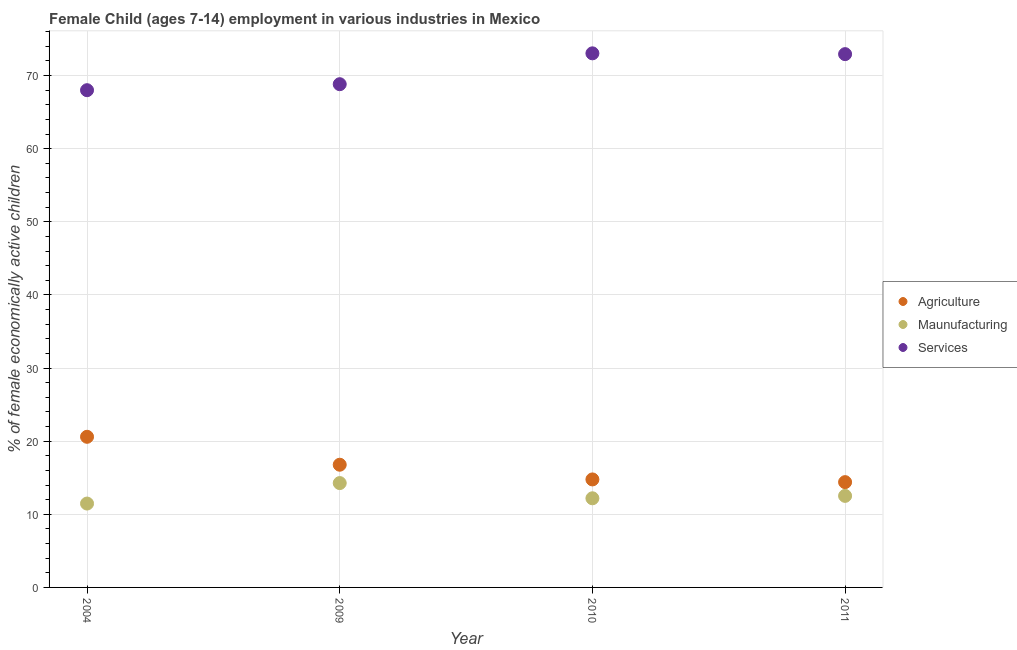How many different coloured dotlines are there?
Your answer should be compact. 3. Is the number of dotlines equal to the number of legend labels?
Give a very brief answer. Yes. What is the percentage of economically active children in manufacturing in 2009?
Give a very brief answer. 14.27. Across all years, what is the maximum percentage of economically active children in agriculture?
Offer a terse response. 20.6. In which year was the percentage of economically active children in services maximum?
Your answer should be very brief. 2010. What is the total percentage of economically active children in agriculture in the graph?
Provide a short and direct response. 66.55. What is the difference between the percentage of economically active children in services in 2004 and that in 2010?
Offer a terse response. -5.04. What is the difference between the percentage of economically active children in agriculture in 2004 and the percentage of economically active children in manufacturing in 2009?
Keep it short and to the point. 6.33. What is the average percentage of economically active children in services per year?
Your answer should be very brief. 70.7. In the year 2009, what is the difference between the percentage of economically active children in manufacturing and percentage of economically active children in agriculture?
Make the answer very short. -2.51. What is the ratio of the percentage of economically active children in services in 2009 to that in 2010?
Make the answer very short. 0.94. Is the difference between the percentage of economically active children in agriculture in 2009 and 2011 greater than the difference between the percentage of economically active children in services in 2009 and 2011?
Offer a terse response. Yes. What is the difference between the highest and the lowest percentage of economically active children in manufacturing?
Make the answer very short. 2.8. In how many years, is the percentage of economically active children in agriculture greater than the average percentage of economically active children in agriculture taken over all years?
Your answer should be compact. 2. Is it the case that in every year, the sum of the percentage of economically active children in agriculture and percentage of economically active children in manufacturing is greater than the percentage of economically active children in services?
Provide a succinct answer. No. Is the percentage of economically active children in manufacturing strictly greater than the percentage of economically active children in services over the years?
Your response must be concise. No. Is the percentage of economically active children in manufacturing strictly less than the percentage of economically active children in services over the years?
Offer a very short reply. Yes. How many dotlines are there?
Ensure brevity in your answer.  3. Does the graph contain any zero values?
Ensure brevity in your answer.  No. Where does the legend appear in the graph?
Ensure brevity in your answer.  Center right. What is the title of the graph?
Your response must be concise. Female Child (ages 7-14) employment in various industries in Mexico. Does "Unpaid family workers" appear as one of the legend labels in the graph?
Offer a terse response. No. What is the label or title of the X-axis?
Your response must be concise. Year. What is the label or title of the Y-axis?
Offer a very short reply. % of female economically active children. What is the % of female economically active children of Agriculture in 2004?
Provide a succinct answer. 20.6. What is the % of female economically active children in Maunufacturing in 2004?
Make the answer very short. 11.47. What is the % of female economically active children of Services in 2004?
Provide a succinct answer. 68. What is the % of female economically active children in Agriculture in 2009?
Your response must be concise. 16.78. What is the % of female economically active children of Maunufacturing in 2009?
Offer a terse response. 14.27. What is the % of female economically active children in Services in 2009?
Provide a short and direct response. 68.82. What is the % of female economically active children of Agriculture in 2010?
Offer a very short reply. 14.77. What is the % of female economically active children in Maunufacturing in 2010?
Ensure brevity in your answer.  12.19. What is the % of female economically active children in Services in 2010?
Offer a very short reply. 73.04. What is the % of female economically active children in Agriculture in 2011?
Provide a succinct answer. 14.4. What is the % of female economically active children of Maunufacturing in 2011?
Provide a short and direct response. 12.52. What is the % of female economically active children in Services in 2011?
Give a very brief answer. 72.93. Across all years, what is the maximum % of female economically active children in Agriculture?
Make the answer very short. 20.6. Across all years, what is the maximum % of female economically active children in Maunufacturing?
Your answer should be compact. 14.27. Across all years, what is the maximum % of female economically active children in Services?
Keep it short and to the point. 73.04. Across all years, what is the minimum % of female economically active children of Agriculture?
Provide a succinct answer. 14.4. Across all years, what is the minimum % of female economically active children of Maunufacturing?
Offer a very short reply. 11.47. Across all years, what is the minimum % of female economically active children of Services?
Offer a very short reply. 68. What is the total % of female economically active children of Agriculture in the graph?
Offer a very short reply. 66.55. What is the total % of female economically active children in Maunufacturing in the graph?
Make the answer very short. 50.45. What is the total % of female economically active children in Services in the graph?
Give a very brief answer. 282.79. What is the difference between the % of female economically active children of Agriculture in 2004 and that in 2009?
Offer a terse response. 3.82. What is the difference between the % of female economically active children in Services in 2004 and that in 2009?
Your answer should be very brief. -0.82. What is the difference between the % of female economically active children in Agriculture in 2004 and that in 2010?
Your answer should be compact. 5.83. What is the difference between the % of female economically active children of Maunufacturing in 2004 and that in 2010?
Your answer should be very brief. -0.72. What is the difference between the % of female economically active children in Services in 2004 and that in 2010?
Keep it short and to the point. -5.04. What is the difference between the % of female economically active children of Agriculture in 2004 and that in 2011?
Provide a short and direct response. 6.2. What is the difference between the % of female economically active children in Maunufacturing in 2004 and that in 2011?
Provide a short and direct response. -1.05. What is the difference between the % of female economically active children in Services in 2004 and that in 2011?
Offer a terse response. -4.93. What is the difference between the % of female economically active children of Agriculture in 2009 and that in 2010?
Offer a very short reply. 2.01. What is the difference between the % of female economically active children of Maunufacturing in 2009 and that in 2010?
Ensure brevity in your answer.  2.08. What is the difference between the % of female economically active children in Services in 2009 and that in 2010?
Keep it short and to the point. -4.22. What is the difference between the % of female economically active children of Agriculture in 2009 and that in 2011?
Your answer should be compact. 2.38. What is the difference between the % of female economically active children of Services in 2009 and that in 2011?
Ensure brevity in your answer.  -4.11. What is the difference between the % of female economically active children in Agriculture in 2010 and that in 2011?
Offer a terse response. 0.37. What is the difference between the % of female economically active children of Maunufacturing in 2010 and that in 2011?
Offer a very short reply. -0.33. What is the difference between the % of female economically active children in Services in 2010 and that in 2011?
Provide a short and direct response. 0.11. What is the difference between the % of female economically active children of Agriculture in 2004 and the % of female economically active children of Maunufacturing in 2009?
Provide a succinct answer. 6.33. What is the difference between the % of female economically active children of Agriculture in 2004 and the % of female economically active children of Services in 2009?
Make the answer very short. -48.22. What is the difference between the % of female economically active children in Maunufacturing in 2004 and the % of female economically active children in Services in 2009?
Offer a terse response. -57.35. What is the difference between the % of female economically active children in Agriculture in 2004 and the % of female economically active children in Maunufacturing in 2010?
Give a very brief answer. 8.41. What is the difference between the % of female economically active children of Agriculture in 2004 and the % of female economically active children of Services in 2010?
Ensure brevity in your answer.  -52.44. What is the difference between the % of female economically active children of Maunufacturing in 2004 and the % of female economically active children of Services in 2010?
Your answer should be very brief. -61.57. What is the difference between the % of female economically active children in Agriculture in 2004 and the % of female economically active children in Maunufacturing in 2011?
Offer a terse response. 8.08. What is the difference between the % of female economically active children of Agriculture in 2004 and the % of female economically active children of Services in 2011?
Offer a terse response. -52.33. What is the difference between the % of female economically active children in Maunufacturing in 2004 and the % of female economically active children in Services in 2011?
Give a very brief answer. -61.46. What is the difference between the % of female economically active children in Agriculture in 2009 and the % of female economically active children in Maunufacturing in 2010?
Keep it short and to the point. 4.59. What is the difference between the % of female economically active children of Agriculture in 2009 and the % of female economically active children of Services in 2010?
Your answer should be very brief. -56.26. What is the difference between the % of female economically active children of Maunufacturing in 2009 and the % of female economically active children of Services in 2010?
Keep it short and to the point. -58.77. What is the difference between the % of female economically active children of Agriculture in 2009 and the % of female economically active children of Maunufacturing in 2011?
Provide a short and direct response. 4.26. What is the difference between the % of female economically active children of Agriculture in 2009 and the % of female economically active children of Services in 2011?
Your answer should be very brief. -56.15. What is the difference between the % of female economically active children of Maunufacturing in 2009 and the % of female economically active children of Services in 2011?
Your response must be concise. -58.66. What is the difference between the % of female economically active children of Agriculture in 2010 and the % of female economically active children of Maunufacturing in 2011?
Ensure brevity in your answer.  2.25. What is the difference between the % of female economically active children in Agriculture in 2010 and the % of female economically active children in Services in 2011?
Offer a very short reply. -58.16. What is the difference between the % of female economically active children of Maunufacturing in 2010 and the % of female economically active children of Services in 2011?
Provide a short and direct response. -60.74. What is the average % of female economically active children in Agriculture per year?
Provide a short and direct response. 16.64. What is the average % of female economically active children of Maunufacturing per year?
Your response must be concise. 12.61. What is the average % of female economically active children of Services per year?
Keep it short and to the point. 70.7. In the year 2004, what is the difference between the % of female economically active children of Agriculture and % of female economically active children of Maunufacturing?
Make the answer very short. 9.13. In the year 2004, what is the difference between the % of female economically active children of Agriculture and % of female economically active children of Services?
Your response must be concise. -47.4. In the year 2004, what is the difference between the % of female economically active children of Maunufacturing and % of female economically active children of Services?
Provide a short and direct response. -56.53. In the year 2009, what is the difference between the % of female economically active children of Agriculture and % of female economically active children of Maunufacturing?
Provide a short and direct response. 2.51. In the year 2009, what is the difference between the % of female economically active children in Agriculture and % of female economically active children in Services?
Your answer should be very brief. -52.04. In the year 2009, what is the difference between the % of female economically active children of Maunufacturing and % of female economically active children of Services?
Your answer should be compact. -54.55. In the year 2010, what is the difference between the % of female economically active children of Agriculture and % of female economically active children of Maunufacturing?
Give a very brief answer. 2.58. In the year 2010, what is the difference between the % of female economically active children in Agriculture and % of female economically active children in Services?
Offer a terse response. -58.27. In the year 2010, what is the difference between the % of female economically active children of Maunufacturing and % of female economically active children of Services?
Your answer should be very brief. -60.85. In the year 2011, what is the difference between the % of female economically active children in Agriculture and % of female economically active children in Maunufacturing?
Your response must be concise. 1.88. In the year 2011, what is the difference between the % of female economically active children in Agriculture and % of female economically active children in Services?
Your response must be concise. -58.53. In the year 2011, what is the difference between the % of female economically active children in Maunufacturing and % of female economically active children in Services?
Offer a terse response. -60.41. What is the ratio of the % of female economically active children in Agriculture in 2004 to that in 2009?
Keep it short and to the point. 1.23. What is the ratio of the % of female economically active children in Maunufacturing in 2004 to that in 2009?
Offer a very short reply. 0.8. What is the ratio of the % of female economically active children in Services in 2004 to that in 2009?
Keep it short and to the point. 0.99. What is the ratio of the % of female economically active children of Agriculture in 2004 to that in 2010?
Your answer should be compact. 1.39. What is the ratio of the % of female economically active children in Maunufacturing in 2004 to that in 2010?
Give a very brief answer. 0.94. What is the ratio of the % of female economically active children in Agriculture in 2004 to that in 2011?
Provide a short and direct response. 1.43. What is the ratio of the % of female economically active children of Maunufacturing in 2004 to that in 2011?
Ensure brevity in your answer.  0.92. What is the ratio of the % of female economically active children of Services in 2004 to that in 2011?
Give a very brief answer. 0.93. What is the ratio of the % of female economically active children of Agriculture in 2009 to that in 2010?
Provide a short and direct response. 1.14. What is the ratio of the % of female economically active children of Maunufacturing in 2009 to that in 2010?
Provide a short and direct response. 1.17. What is the ratio of the % of female economically active children in Services in 2009 to that in 2010?
Provide a short and direct response. 0.94. What is the ratio of the % of female economically active children in Agriculture in 2009 to that in 2011?
Offer a terse response. 1.17. What is the ratio of the % of female economically active children in Maunufacturing in 2009 to that in 2011?
Your response must be concise. 1.14. What is the ratio of the % of female economically active children of Services in 2009 to that in 2011?
Provide a succinct answer. 0.94. What is the ratio of the % of female economically active children of Agriculture in 2010 to that in 2011?
Offer a terse response. 1.03. What is the ratio of the % of female economically active children in Maunufacturing in 2010 to that in 2011?
Your response must be concise. 0.97. What is the difference between the highest and the second highest % of female economically active children of Agriculture?
Make the answer very short. 3.82. What is the difference between the highest and the second highest % of female economically active children in Maunufacturing?
Make the answer very short. 1.75. What is the difference between the highest and the second highest % of female economically active children in Services?
Give a very brief answer. 0.11. What is the difference between the highest and the lowest % of female economically active children in Maunufacturing?
Offer a terse response. 2.8. What is the difference between the highest and the lowest % of female economically active children of Services?
Make the answer very short. 5.04. 